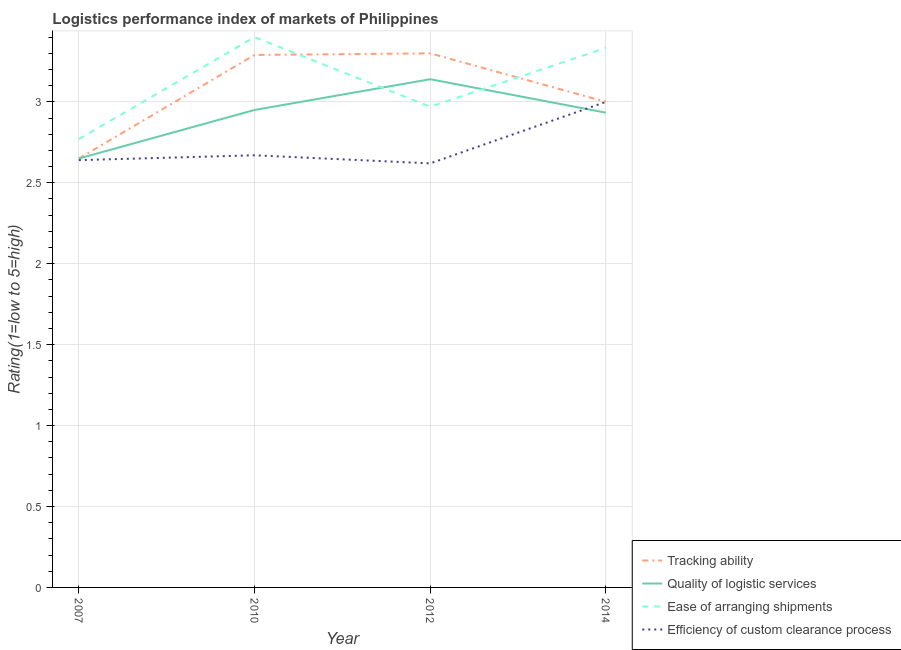Does the line corresponding to lpi rating of efficiency of custom clearance process intersect with the line corresponding to lpi rating of ease of arranging shipments?
Make the answer very short. No. Is the number of lines equal to the number of legend labels?
Offer a terse response. Yes. What is the lpi rating of efficiency of custom clearance process in 2012?
Make the answer very short. 2.62. Across all years, what is the maximum lpi rating of quality of logistic services?
Your response must be concise. 3.14. Across all years, what is the minimum lpi rating of quality of logistic services?
Your response must be concise. 2.65. What is the total lpi rating of quality of logistic services in the graph?
Provide a short and direct response. 11.67. What is the difference between the lpi rating of ease of arranging shipments in 2007 and that in 2014?
Give a very brief answer. -0.56. What is the difference between the lpi rating of quality of logistic services in 2012 and the lpi rating of tracking ability in 2010?
Make the answer very short. -0.15. What is the average lpi rating of ease of arranging shipments per year?
Keep it short and to the point. 3.12. In the year 2012, what is the difference between the lpi rating of quality of logistic services and lpi rating of ease of arranging shipments?
Ensure brevity in your answer.  0.17. What is the ratio of the lpi rating of quality of logistic services in 2010 to that in 2012?
Provide a short and direct response. 0.94. Is the lpi rating of quality of logistic services in 2007 less than that in 2012?
Offer a terse response. Yes. What is the difference between the highest and the second highest lpi rating of efficiency of custom clearance process?
Offer a terse response. 0.33. What is the difference between the highest and the lowest lpi rating of efficiency of custom clearance process?
Your answer should be very brief. 0.38. In how many years, is the lpi rating of efficiency of custom clearance process greater than the average lpi rating of efficiency of custom clearance process taken over all years?
Make the answer very short. 1. Is it the case that in every year, the sum of the lpi rating of quality of logistic services and lpi rating of ease of arranging shipments is greater than the sum of lpi rating of tracking ability and lpi rating of efficiency of custom clearance process?
Ensure brevity in your answer.  No. Is the lpi rating of efficiency of custom clearance process strictly less than the lpi rating of ease of arranging shipments over the years?
Your answer should be very brief. Yes. How many lines are there?
Give a very brief answer. 4. How many years are there in the graph?
Keep it short and to the point. 4. What is the difference between two consecutive major ticks on the Y-axis?
Keep it short and to the point. 0.5. Are the values on the major ticks of Y-axis written in scientific E-notation?
Offer a very short reply. No. Does the graph contain any zero values?
Make the answer very short. No. Does the graph contain grids?
Your answer should be very brief. Yes. What is the title of the graph?
Make the answer very short. Logistics performance index of markets of Philippines. Does "Quality of public administration" appear as one of the legend labels in the graph?
Provide a succinct answer. No. What is the label or title of the Y-axis?
Keep it short and to the point. Rating(1=low to 5=high). What is the Rating(1=low to 5=high) of Tracking ability in 2007?
Your answer should be compact. 2.65. What is the Rating(1=low to 5=high) in Quality of logistic services in 2007?
Keep it short and to the point. 2.65. What is the Rating(1=low to 5=high) of Ease of arranging shipments in 2007?
Offer a terse response. 2.77. What is the Rating(1=low to 5=high) of Efficiency of custom clearance process in 2007?
Ensure brevity in your answer.  2.64. What is the Rating(1=low to 5=high) of Tracking ability in 2010?
Ensure brevity in your answer.  3.29. What is the Rating(1=low to 5=high) of Quality of logistic services in 2010?
Your answer should be very brief. 2.95. What is the Rating(1=low to 5=high) in Efficiency of custom clearance process in 2010?
Ensure brevity in your answer.  2.67. What is the Rating(1=low to 5=high) of Quality of logistic services in 2012?
Provide a succinct answer. 3.14. What is the Rating(1=low to 5=high) in Ease of arranging shipments in 2012?
Your answer should be compact. 2.97. What is the Rating(1=low to 5=high) of Efficiency of custom clearance process in 2012?
Your answer should be very brief. 2.62. What is the Rating(1=low to 5=high) in Tracking ability in 2014?
Your answer should be very brief. 3. What is the Rating(1=low to 5=high) of Quality of logistic services in 2014?
Give a very brief answer. 2.93. What is the Rating(1=low to 5=high) in Ease of arranging shipments in 2014?
Give a very brief answer. 3.33. What is the Rating(1=low to 5=high) in Efficiency of custom clearance process in 2014?
Your answer should be very brief. 3. Across all years, what is the maximum Rating(1=low to 5=high) of Tracking ability?
Make the answer very short. 3.3. Across all years, what is the maximum Rating(1=low to 5=high) in Quality of logistic services?
Your response must be concise. 3.14. Across all years, what is the minimum Rating(1=low to 5=high) in Tracking ability?
Provide a short and direct response. 2.65. Across all years, what is the minimum Rating(1=low to 5=high) of Quality of logistic services?
Keep it short and to the point. 2.65. Across all years, what is the minimum Rating(1=low to 5=high) of Ease of arranging shipments?
Make the answer very short. 2.77. Across all years, what is the minimum Rating(1=low to 5=high) in Efficiency of custom clearance process?
Your answer should be very brief. 2.62. What is the total Rating(1=low to 5=high) in Tracking ability in the graph?
Your response must be concise. 12.24. What is the total Rating(1=low to 5=high) of Quality of logistic services in the graph?
Ensure brevity in your answer.  11.67. What is the total Rating(1=low to 5=high) in Ease of arranging shipments in the graph?
Your answer should be compact. 12.47. What is the total Rating(1=low to 5=high) in Efficiency of custom clearance process in the graph?
Give a very brief answer. 10.93. What is the difference between the Rating(1=low to 5=high) of Tracking ability in 2007 and that in 2010?
Ensure brevity in your answer.  -0.64. What is the difference between the Rating(1=low to 5=high) of Quality of logistic services in 2007 and that in 2010?
Offer a terse response. -0.3. What is the difference between the Rating(1=low to 5=high) of Ease of arranging shipments in 2007 and that in 2010?
Your answer should be very brief. -0.63. What is the difference between the Rating(1=low to 5=high) of Efficiency of custom clearance process in 2007 and that in 2010?
Ensure brevity in your answer.  -0.03. What is the difference between the Rating(1=low to 5=high) of Tracking ability in 2007 and that in 2012?
Provide a succinct answer. -0.65. What is the difference between the Rating(1=low to 5=high) of Quality of logistic services in 2007 and that in 2012?
Provide a succinct answer. -0.49. What is the difference between the Rating(1=low to 5=high) of Tracking ability in 2007 and that in 2014?
Offer a terse response. -0.35. What is the difference between the Rating(1=low to 5=high) in Quality of logistic services in 2007 and that in 2014?
Ensure brevity in your answer.  -0.28. What is the difference between the Rating(1=low to 5=high) in Ease of arranging shipments in 2007 and that in 2014?
Your answer should be compact. -0.56. What is the difference between the Rating(1=low to 5=high) of Efficiency of custom clearance process in 2007 and that in 2014?
Make the answer very short. -0.36. What is the difference between the Rating(1=low to 5=high) in Tracking ability in 2010 and that in 2012?
Provide a short and direct response. -0.01. What is the difference between the Rating(1=low to 5=high) of Quality of logistic services in 2010 and that in 2012?
Ensure brevity in your answer.  -0.19. What is the difference between the Rating(1=low to 5=high) of Ease of arranging shipments in 2010 and that in 2012?
Offer a terse response. 0.43. What is the difference between the Rating(1=low to 5=high) of Tracking ability in 2010 and that in 2014?
Your response must be concise. 0.29. What is the difference between the Rating(1=low to 5=high) in Quality of logistic services in 2010 and that in 2014?
Make the answer very short. 0.02. What is the difference between the Rating(1=low to 5=high) in Ease of arranging shipments in 2010 and that in 2014?
Offer a terse response. 0.07. What is the difference between the Rating(1=low to 5=high) of Efficiency of custom clearance process in 2010 and that in 2014?
Give a very brief answer. -0.33. What is the difference between the Rating(1=low to 5=high) in Tracking ability in 2012 and that in 2014?
Provide a short and direct response. 0.3. What is the difference between the Rating(1=low to 5=high) of Quality of logistic services in 2012 and that in 2014?
Ensure brevity in your answer.  0.21. What is the difference between the Rating(1=low to 5=high) in Ease of arranging shipments in 2012 and that in 2014?
Your answer should be compact. -0.36. What is the difference between the Rating(1=low to 5=high) of Efficiency of custom clearance process in 2012 and that in 2014?
Your answer should be compact. -0.38. What is the difference between the Rating(1=low to 5=high) of Tracking ability in 2007 and the Rating(1=low to 5=high) of Quality of logistic services in 2010?
Provide a short and direct response. -0.3. What is the difference between the Rating(1=low to 5=high) in Tracking ability in 2007 and the Rating(1=low to 5=high) in Ease of arranging shipments in 2010?
Keep it short and to the point. -0.75. What is the difference between the Rating(1=low to 5=high) of Tracking ability in 2007 and the Rating(1=low to 5=high) of Efficiency of custom clearance process in 2010?
Keep it short and to the point. -0.02. What is the difference between the Rating(1=low to 5=high) of Quality of logistic services in 2007 and the Rating(1=low to 5=high) of Ease of arranging shipments in 2010?
Provide a succinct answer. -0.75. What is the difference between the Rating(1=low to 5=high) in Quality of logistic services in 2007 and the Rating(1=low to 5=high) in Efficiency of custom clearance process in 2010?
Offer a terse response. -0.02. What is the difference between the Rating(1=low to 5=high) of Tracking ability in 2007 and the Rating(1=low to 5=high) of Quality of logistic services in 2012?
Your response must be concise. -0.49. What is the difference between the Rating(1=low to 5=high) of Tracking ability in 2007 and the Rating(1=low to 5=high) of Ease of arranging shipments in 2012?
Provide a short and direct response. -0.32. What is the difference between the Rating(1=low to 5=high) of Quality of logistic services in 2007 and the Rating(1=low to 5=high) of Ease of arranging shipments in 2012?
Your response must be concise. -0.32. What is the difference between the Rating(1=low to 5=high) of Quality of logistic services in 2007 and the Rating(1=low to 5=high) of Efficiency of custom clearance process in 2012?
Provide a succinct answer. 0.03. What is the difference between the Rating(1=low to 5=high) in Ease of arranging shipments in 2007 and the Rating(1=low to 5=high) in Efficiency of custom clearance process in 2012?
Your answer should be compact. 0.15. What is the difference between the Rating(1=low to 5=high) of Tracking ability in 2007 and the Rating(1=low to 5=high) of Quality of logistic services in 2014?
Make the answer very short. -0.28. What is the difference between the Rating(1=low to 5=high) in Tracking ability in 2007 and the Rating(1=low to 5=high) in Ease of arranging shipments in 2014?
Your answer should be very brief. -0.68. What is the difference between the Rating(1=low to 5=high) in Tracking ability in 2007 and the Rating(1=low to 5=high) in Efficiency of custom clearance process in 2014?
Your response must be concise. -0.35. What is the difference between the Rating(1=low to 5=high) of Quality of logistic services in 2007 and the Rating(1=low to 5=high) of Ease of arranging shipments in 2014?
Provide a short and direct response. -0.68. What is the difference between the Rating(1=low to 5=high) of Quality of logistic services in 2007 and the Rating(1=low to 5=high) of Efficiency of custom clearance process in 2014?
Ensure brevity in your answer.  -0.35. What is the difference between the Rating(1=low to 5=high) in Ease of arranging shipments in 2007 and the Rating(1=low to 5=high) in Efficiency of custom clearance process in 2014?
Offer a terse response. -0.23. What is the difference between the Rating(1=low to 5=high) in Tracking ability in 2010 and the Rating(1=low to 5=high) in Ease of arranging shipments in 2012?
Provide a succinct answer. 0.32. What is the difference between the Rating(1=low to 5=high) in Tracking ability in 2010 and the Rating(1=low to 5=high) in Efficiency of custom clearance process in 2012?
Ensure brevity in your answer.  0.67. What is the difference between the Rating(1=low to 5=high) in Quality of logistic services in 2010 and the Rating(1=low to 5=high) in Ease of arranging shipments in 2012?
Ensure brevity in your answer.  -0.02. What is the difference between the Rating(1=low to 5=high) of Quality of logistic services in 2010 and the Rating(1=low to 5=high) of Efficiency of custom clearance process in 2012?
Offer a terse response. 0.33. What is the difference between the Rating(1=low to 5=high) in Ease of arranging shipments in 2010 and the Rating(1=low to 5=high) in Efficiency of custom clearance process in 2012?
Your response must be concise. 0.78. What is the difference between the Rating(1=low to 5=high) of Tracking ability in 2010 and the Rating(1=low to 5=high) of Quality of logistic services in 2014?
Your answer should be very brief. 0.36. What is the difference between the Rating(1=low to 5=high) of Tracking ability in 2010 and the Rating(1=low to 5=high) of Ease of arranging shipments in 2014?
Your response must be concise. -0.04. What is the difference between the Rating(1=low to 5=high) in Tracking ability in 2010 and the Rating(1=low to 5=high) in Efficiency of custom clearance process in 2014?
Offer a terse response. 0.29. What is the difference between the Rating(1=low to 5=high) in Quality of logistic services in 2010 and the Rating(1=low to 5=high) in Ease of arranging shipments in 2014?
Offer a terse response. -0.38. What is the difference between the Rating(1=low to 5=high) of Quality of logistic services in 2010 and the Rating(1=low to 5=high) of Efficiency of custom clearance process in 2014?
Provide a short and direct response. -0.05. What is the difference between the Rating(1=low to 5=high) in Ease of arranging shipments in 2010 and the Rating(1=low to 5=high) in Efficiency of custom clearance process in 2014?
Your answer should be compact. 0.4. What is the difference between the Rating(1=low to 5=high) in Tracking ability in 2012 and the Rating(1=low to 5=high) in Quality of logistic services in 2014?
Make the answer very short. 0.37. What is the difference between the Rating(1=low to 5=high) of Tracking ability in 2012 and the Rating(1=low to 5=high) of Ease of arranging shipments in 2014?
Provide a short and direct response. -0.03. What is the difference between the Rating(1=low to 5=high) in Quality of logistic services in 2012 and the Rating(1=low to 5=high) in Ease of arranging shipments in 2014?
Offer a very short reply. -0.19. What is the difference between the Rating(1=low to 5=high) of Quality of logistic services in 2012 and the Rating(1=low to 5=high) of Efficiency of custom clearance process in 2014?
Ensure brevity in your answer.  0.14. What is the difference between the Rating(1=low to 5=high) of Ease of arranging shipments in 2012 and the Rating(1=low to 5=high) of Efficiency of custom clearance process in 2014?
Make the answer very short. -0.03. What is the average Rating(1=low to 5=high) of Tracking ability per year?
Your answer should be compact. 3.06. What is the average Rating(1=low to 5=high) in Quality of logistic services per year?
Your response must be concise. 2.92. What is the average Rating(1=low to 5=high) of Ease of arranging shipments per year?
Your answer should be very brief. 3.12. What is the average Rating(1=low to 5=high) of Efficiency of custom clearance process per year?
Offer a very short reply. 2.73. In the year 2007, what is the difference between the Rating(1=low to 5=high) in Tracking ability and Rating(1=low to 5=high) in Quality of logistic services?
Give a very brief answer. 0. In the year 2007, what is the difference between the Rating(1=low to 5=high) of Tracking ability and Rating(1=low to 5=high) of Ease of arranging shipments?
Offer a very short reply. -0.12. In the year 2007, what is the difference between the Rating(1=low to 5=high) of Quality of logistic services and Rating(1=low to 5=high) of Ease of arranging shipments?
Your answer should be compact. -0.12. In the year 2007, what is the difference between the Rating(1=low to 5=high) of Ease of arranging shipments and Rating(1=low to 5=high) of Efficiency of custom clearance process?
Provide a succinct answer. 0.13. In the year 2010, what is the difference between the Rating(1=low to 5=high) in Tracking ability and Rating(1=low to 5=high) in Quality of logistic services?
Make the answer very short. 0.34. In the year 2010, what is the difference between the Rating(1=low to 5=high) in Tracking ability and Rating(1=low to 5=high) in Ease of arranging shipments?
Offer a very short reply. -0.11. In the year 2010, what is the difference between the Rating(1=low to 5=high) in Tracking ability and Rating(1=low to 5=high) in Efficiency of custom clearance process?
Provide a succinct answer. 0.62. In the year 2010, what is the difference between the Rating(1=low to 5=high) in Quality of logistic services and Rating(1=low to 5=high) in Ease of arranging shipments?
Keep it short and to the point. -0.45. In the year 2010, what is the difference between the Rating(1=low to 5=high) of Quality of logistic services and Rating(1=low to 5=high) of Efficiency of custom clearance process?
Offer a very short reply. 0.28. In the year 2010, what is the difference between the Rating(1=low to 5=high) of Ease of arranging shipments and Rating(1=low to 5=high) of Efficiency of custom clearance process?
Your response must be concise. 0.73. In the year 2012, what is the difference between the Rating(1=low to 5=high) in Tracking ability and Rating(1=low to 5=high) in Quality of logistic services?
Keep it short and to the point. 0.16. In the year 2012, what is the difference between the Rating(1=low to 5=high) of Tracking ability and Rating(1=low to 5=high) of Ease of arranging shipments?
Provide a short and direct response. 0.33. In the year 2012, what is the difference between the Rating(1=low to 5=high) of Tracking ability and Rating(1=low to 5=high) of Efficiency of custom clearance process?
Make the answer very short. 0.68. In the year 2012, what is the difference between the Rating(1=low to 5=high) in Quality of logistic services and Rating(1=low to 5=high) in Ease of arranging shipments?
Your answer should be compact. 0.17. In the year 2012, what is the difference between the Rating(1=low to 5=high) in Quality of logistic services and Rating(1=low to 5=high) in Efficiency of custom clearance process?
Your answer should be compact. 0.52. In the year 2014, what is the difference between the Rating(1=low to 5=high) of Tracking ability and Rating(1=low to 5=high) of Quality of logistic services?
Offer a terse response. 0.07. In the year 2014, what is the difference between the Rating(1=low to 5=high) in Tracking ability and Rating(1=low to 5=high) in Efficiency of custom clearance process?
Offer a very short reply. 0. In the year 2014, what is the difference between the Rating(1=low to 5=high) of Quality of logistic services and Rating(1=low to 5=high) of Ease of arranging shipments?
Make the answer very short. -0.4. In the year 2014, what is the difference between the Rating(1=low to 5=high) of Quality of logistic services and Rating(1=low to 5=high) of Efficiency of custom clearance process?
Provide a short and direct response. -0.07. What is the ratio of the Rating(1=low to 5=high) in Tracking ability in 2007 to that in 2010?
Your response must be concise. 0.81. What is the ratio of the Rating(1=low to 5=high) in Quality of logistic services in 2007 to that in 2010?
Provide a succinct answer. 0.9. What is the ratio of the Rating(1=low to 5=high) in Ease of arranging shipments in 2007 to that in 2010?
Offer a terse response. 0.81. What is the ratio of the Rating(1=low to 5=high) in Tracking ability in 2007 to that in 2012?
Give a very brief answer. 0.8. What is the ratio of the Rating(1=low to 5=high) of Quality of logistic services in 2007 to that in 2012?
Keep it short and to the point. 0.84. What is the ratio of the Rating(1=low to 5=high) in Ease of arranging shipments in 2007 to that in 2012?
Make the answer very short. 0.93. What is the ratio of the Rating(1=low to 5=high) in Efficiency of custom clearance process in 2007 to that in 2012?
Offer a very short reply. 1.01. What is the ratio of the Rating(1=low to 5=high) in Tracking ability in 2007 to that in 2014?
Offer a terse response. 0.88. What is the ratio of the Rating(1=low to 5=high) of Quality of logistic services in 2007 to that in 2014?
Provide a short and direct response. 0.9. What is the ratio of the Rating(1=low to 5=high) in Ease of arranging shipments in 2007 to that in 2014?
Your response must be concise. 0.83. What is the ratio of the Rating(1=low to 5=high) of Quality of logistic services in 2010 to that in 2012?
Your response must be concise. 0.94. What is the ratio of the Rating(1=low to 5=high) in Ease of arranging shipments in 2010 to that in 2012?
Your response must be concise. 1.14. What is the ratio of the Rating(1=low to 5=high) of Efficiency of custom clearance process in 2010 to that in 2012?
Your response must be concise. 1.02. What is the ratio of the Rating(1=low to 5=high) in Tracking ability in 2010 to that in 2014?
Ensure brevity in your answer.  1.1. What is the ratio of the Rating(1=low to 5=high) of Efficiency of custom clearance process in 2010 to that in 2014?
Give a very brief answer. 0.89. What is the ratio of the Rating(1=low to 5=high) of Quality of logistic services in 2012 to that in 2014?
Ensure brevity in your answer.  1.07. What is the ratio of the Rating(1=low to 5=high) in Ease of arranging shipments in 2012 to that in 2014?
Make the answer very short. 0.89. What is the ratio of the Rating(1=low to 5=high) in Efficiency of custom clearance process in 2012 to that in 2014?
Offer a very short reply. 0.87. What is the difference between the highest and the second highest Rating(1=low to 5=high) in Quality of logistic services?
Offer a very short reply. 0.19. What is the difference between the highest and the second highest Rating(1=low to 5=high) in Ease of arranging shipments?
Keep it short and to the point. 0.07. What is the difference between the highest and the second highest Rating(1=low to 5=high) in Efficiency of custom clearance process?
Keep it short and to the point. 0.33. What is the difference between the highest and the lowest Rating(1=low to 5=high) in Tracking ability?
Give a very brief answer. 0.65. What is the difference between the highest and the lowest Rating(1=low to 5=high) of Quality of logistic services?
Your response must be concise. 0.49. What is the difference between the highest and the lowest Rating(1=low to 5=high) in Ease of arranging shipments?
Offer a terse response. 0.63. What is the difference between the highest and the lowest Rating(1=low to 5=high) of Efficiency of custom clearance process?
Keep it short and to the point. 0.38. 